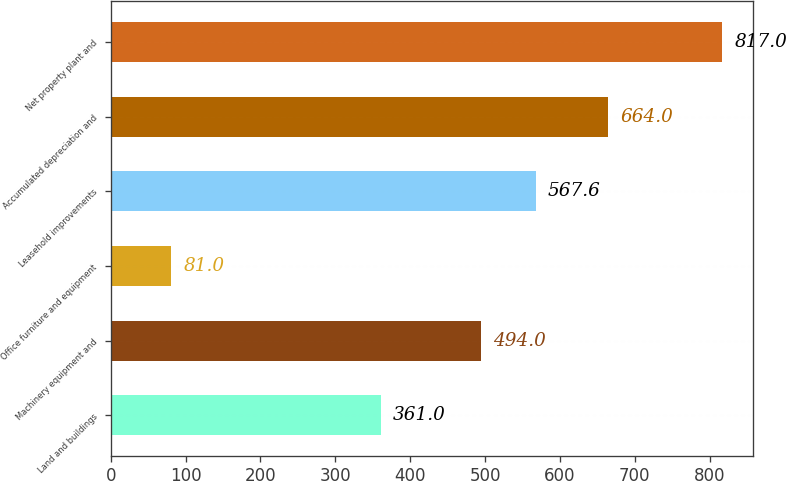Convert chart. <chart><loc_0><loc_0><loc_500><loc_500><bar_chart><fcel>Land and buildings<fcel>Machinery equipment and<fcel>Office furniture and equipment<fcel>Leasehold improvements<fcel>Accumulated depreciation and<fcel>Net property plant and<nl><fcel>361<fcel>494<fcel>81<fcel>567.6<fcel>664<fcel>817<nl></chart> 